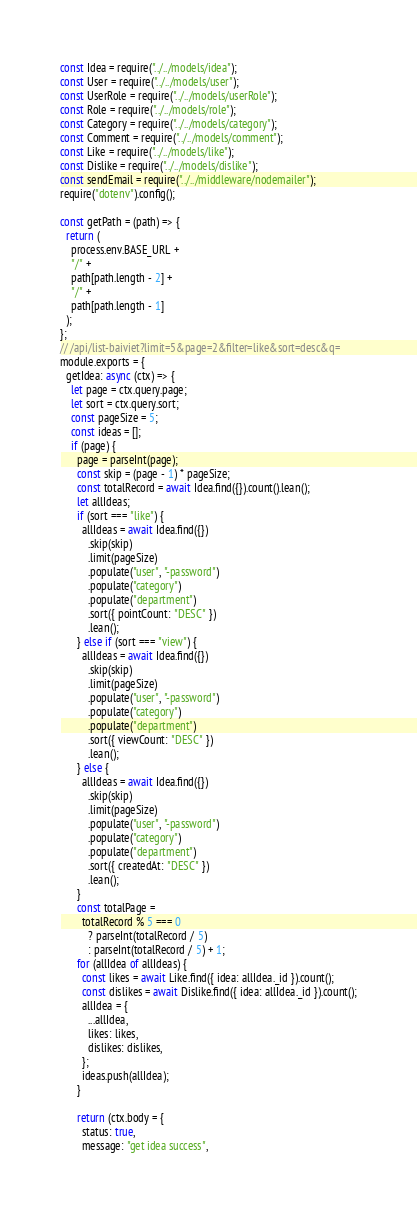Convert code to text. <code><loc_0><loc_0><loc_500><loc_500><_JavaScript_>const Idea = require("../../models/idea");
const User = require("../../models/user");
const UserRole = require("../../models/userRole");
const Role = require("../../models/role");
const Category = require("../../models/category");
const Comment = require("../../models/comment");
const Like = require("../../models/like");
const Dislike = require("../../models/dislike");
const sendEmail = require("../../middleware/nodemailer");
require("dotenv").config();

const getPath = (path) => {
  return (
    process.env.BASE_URL +
    "/" +
    path[path.length - 2] +
    "/" +
    path[path.length - 1]
  );
};
// /api/list-baiviet?limit=5&page=2&filter=like&sort=desc&q=
module.exports = {
  getIdea: async (ctx) => {
    let page = ctx.query.page;
    let sort = ctx.query.sort;
    const pageSize = 5;
    const ideas = [];
    if (page) {
      page = parseInt(page);
      const skip = (page - 1) * pageSize;
      const totalRecord = await Idea.find({}).count().lean();
      let allIdeas;
      if (sort === "like") {
        allIdeas = await Idea.find({})
          .skip(skip)
          .limit(pageSize)
          .populate("user", "-password")
          .populate("category")
          .populate("department")
          .sort({ pointCount: "DESC" })
          .lean();
      } else if (sort === "view") {
        allIdeas = await Idea.find({})
          .skip(skip)
          .limit(pageSize)
          .populate("user", "-password")
          .populate("category")
          .populate("department")
          .sort({ viewCount: "DESC" })
          .lean();
      } else {
        allIdeas = await Idea.find({})
          .skip(skip)
          .limit(pageSize)
          .populate("user", "-password")
          .populate("category")
          .populate("department")
          .sort({ createdAt: "DESC" })
          .lean();
      }
      const totalPage =
        totalRecord % 5 === 0
          ? parseInt(totalRecord / 5)
          : parseInt(totalRecord / 5) + 1;
      for (allIdea of allIdeas) {
        const likes = await Like.find({ idea: allIdea._id }).count();
        const dislikes = await Dislike.find({ idea: allIdea._id }).count();
        allIdea = {
          ...allIdea,
          likes: likes,
          dislikes: dislikes,
        };
        ideas.push(allIdea);
      }

      return (ctx.body = {
        status: true,
        message: "get idea success",</code> 